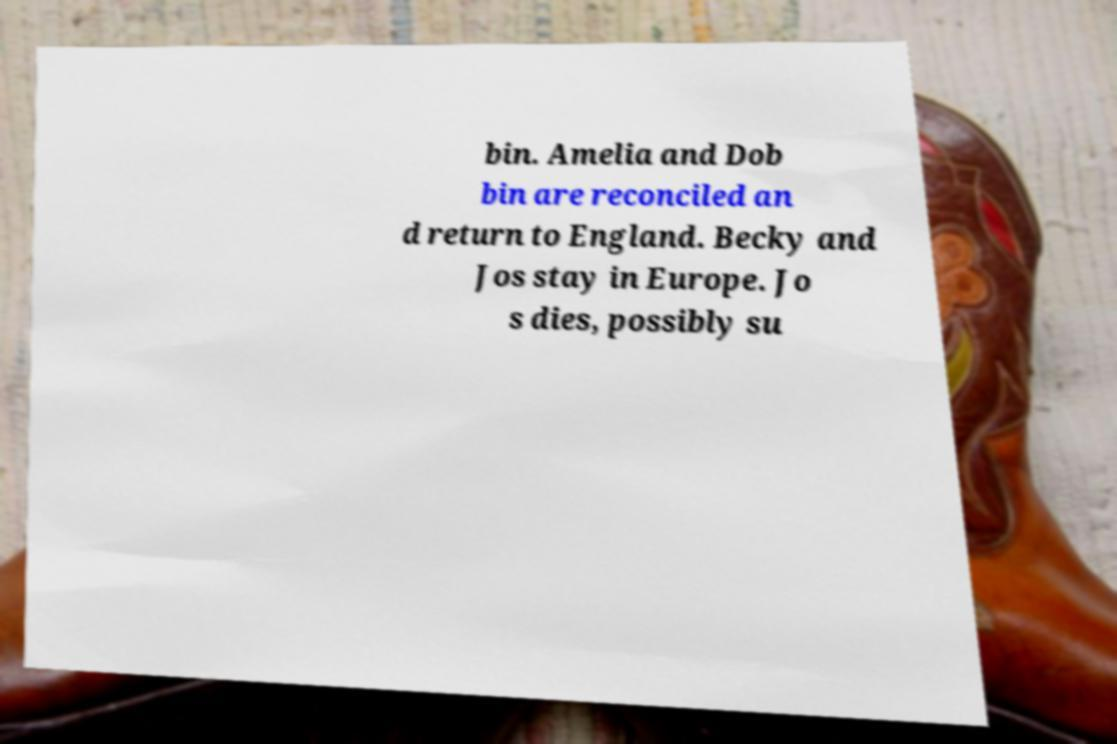Can you accurately transcribe the text from the provided image for me? bin. Amelia and Dob bin are reconciled an d return to England. Becky and Jos stay in Europe. Jo s dies, possibly su 